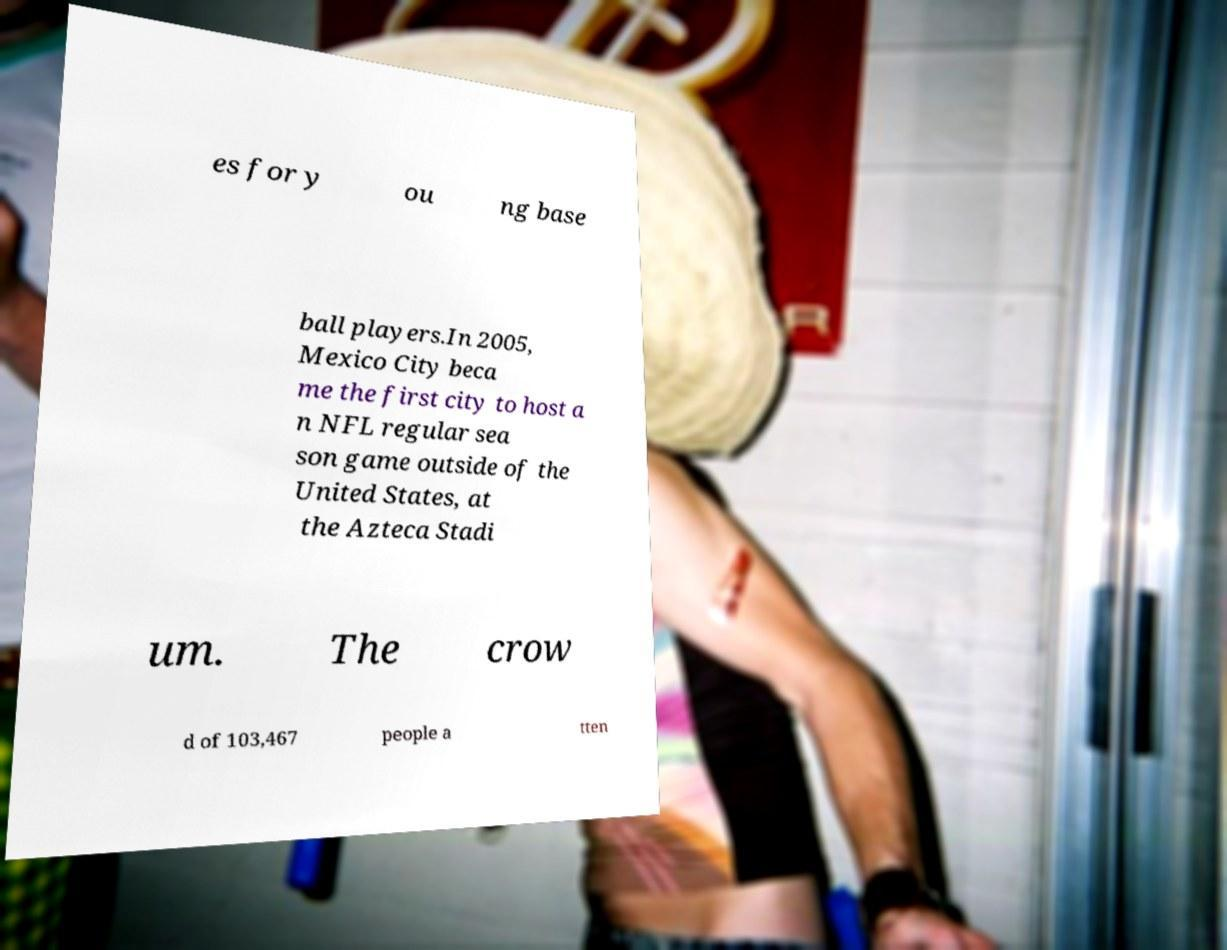For documentation purposes, I need the text within this image transcribed. Could you provide that? es for y ou ng base ball players.In 2005, Mexico City beca me the first city to host a n NFL regular sea son game outside of the United States, at the Azteca Stadi um. The crow d of 103,467 people a tten 